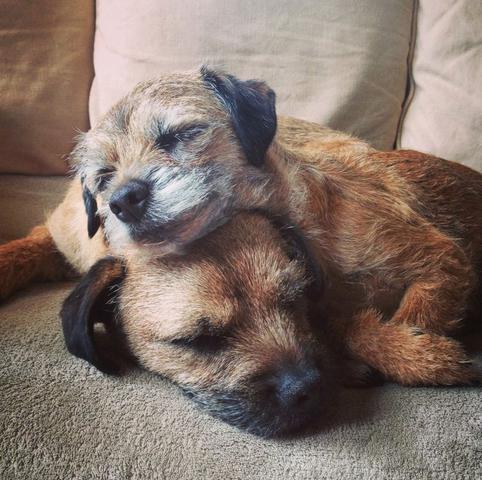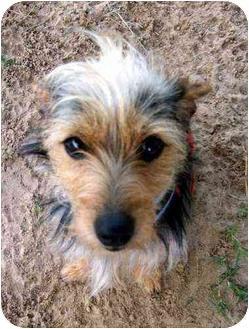The first image is the image on the left, the second image is the image on the right. Examine the images to the left and right. Is the description "An image shows a dog in a sleeping pose on a patterned fabric." accurate? Answer yes or no. No. The first image is the image on the left, the second image is the image on the right. Examine the images to the left and right. Is the description "There are three dogs,  dog on the right is looking straight at the camera, as if making eye contact." accurate? Answer yes or no. Yes. 